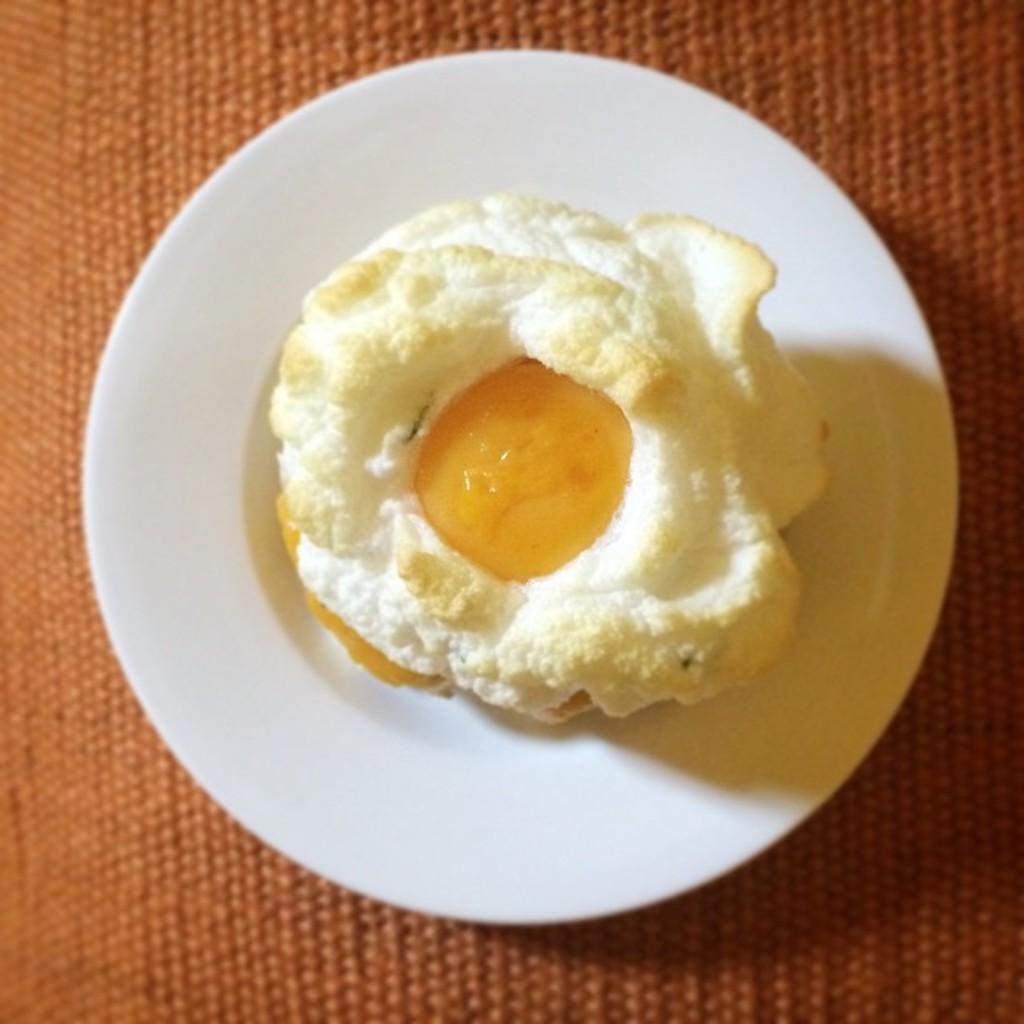In one or two sentences, can you explain what this image depicts? In the center of the image we can see an egg poach and a plate placed on the table. 